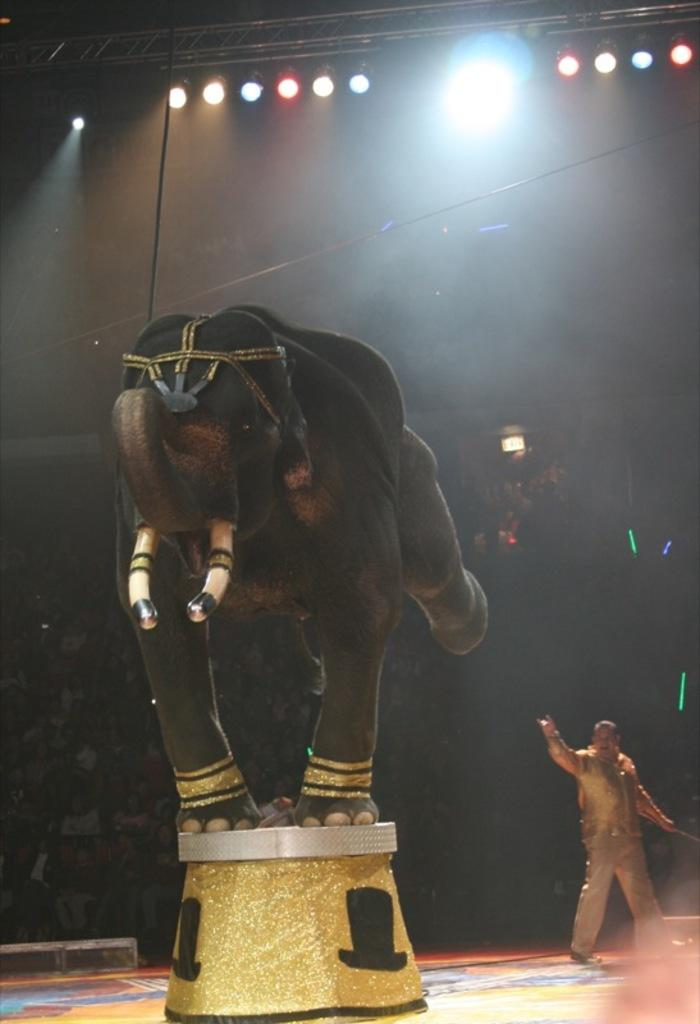What animal is the main subject of the picture? There is an elephant in the picture. How is the elephant positioned in the image? The elephant is standing on a stone with two legs. Can you describe anything else be seen behind the elephant? Yes, there is a man standing behind the elephant. What type of lighting is present in the image? There is a light on the ceiling in the image. What type of cord is the elephant holding in the image? There is no cord present in the image; the elephant is standing on a stone with two legs. 